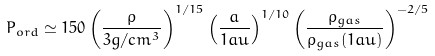Convert formula to latex. <formula><loc_0><loc_0><loc_500><loc_500>P _ { o r d } \simeq 1 5 0 \left ( \frac { \rho } { 3 g / c m ^ { 3 } } \right ) ^ { 1 / 1 5 } \left ( \frac { a } { 1 a u } \right ) ^ { 1 / 1 0 } \left ( \frac { \rho _ { g a s } } { \rho _ { g a s } ( 1 a u ) } \right ) ^ { - 2 / 5 }</formula> 